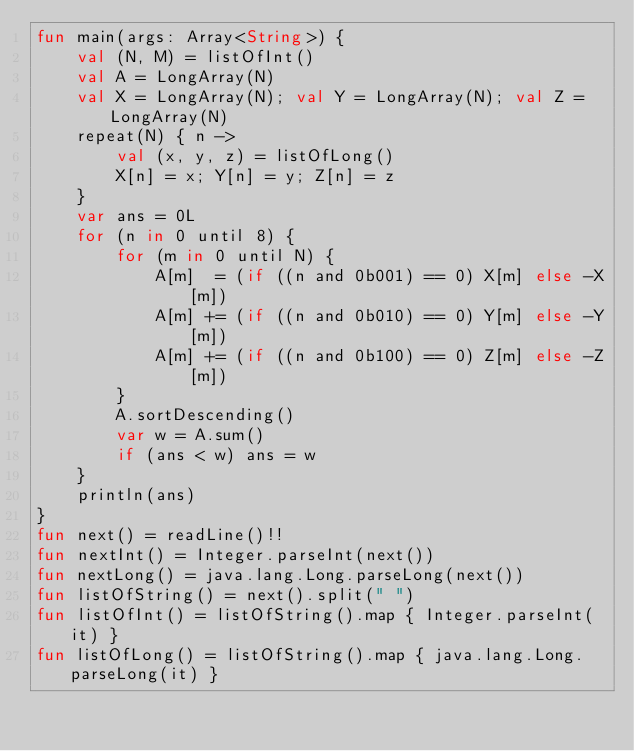<code> <loc_0><loc_0><loc_500><loc_500><_Kotlin_>fun main(args: Array<String>) {
    val (N, M) = listOfInt()
    val A = LongArray(N)
    val X = LongArray(N); val Y = LongArray(N); val Z = LongArray(N)
    repeat(N) { n ->
        val (x, y, z) = listOfLong()
        X[n] = x; Y[n] = y; Z[n] = z
    }
    var ans = 0L
    for (n in 0 until 8) {
        for (m in 0 until N) {
            A[m]  = (if ((n and 0b001) == 0) X[m] else -X[m])
            A[m] += (if ((n and 0b010) == 0) Y[m] else -Y[m])
            A[m] += (if ((n and 0b100) == 0) Z[m] else -Z[m])
        }
        A.sortDescending()
        var w = A.sum()
        if (ans < w) ans = w
    }
    println(ans)
}
fun next() = readLine()!!
fun nextInt() = Integer.parseInt(next())
fun nextLong() = java.lang.Long.parseLong(next())
fun listOfString() = next().split(" ")
fun listOfInt() = listOfString().map { Integer.parseInt(it) }
fun listOfLong() = listOfString().map { java.lang.Long.parseLong(it) }
</code> 